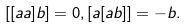<formula> <loc_0><loc_0><loc_500><loc_500>[ [ { a a } ] { b } ] = 0 , [ { a } [ { a b } ] ] = - { b } .</formula> 